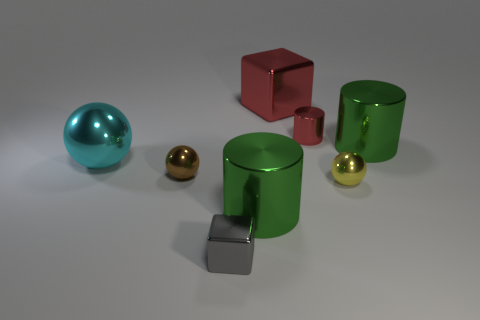What colors are the objects in the image? In the image, we have objects in a variety of colors including teal, gold, green, red, and gray. 